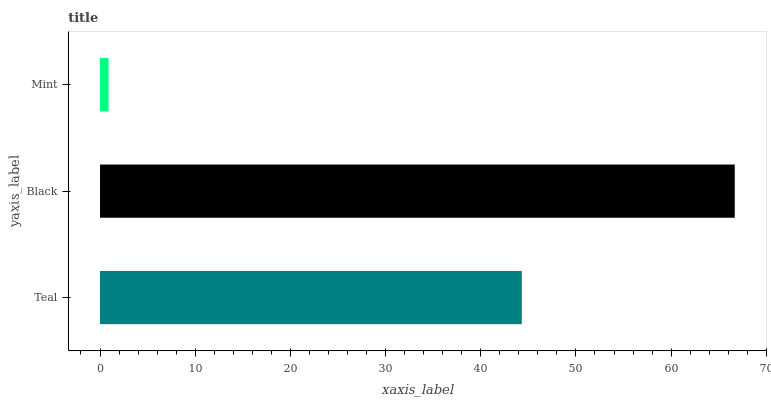Is Mint the minimum?
Answer yes or no. Yes. Is Black the maximum?
Answer yes or no. Yes. Is Black the minimum?
Answer yes or no. No. Is Mint the maximum?
Answer yes or no. No. Is Black greater than Mint?
Answer yes or no. Yes. Is Mint less than Black?
Answer yes or no. Yes. Is Mint greater than Black?
Answer yes or no. No. Is Black less than Mint?
Answer yes or no. No. Is Teal the high median?
Answer yes or no. Yes. Is Teal the low median?
Answer yes or no. Yes. Is Black the high median?
Answer yes or no. No. Is Mint the low median?
Answer yes or no. No. 